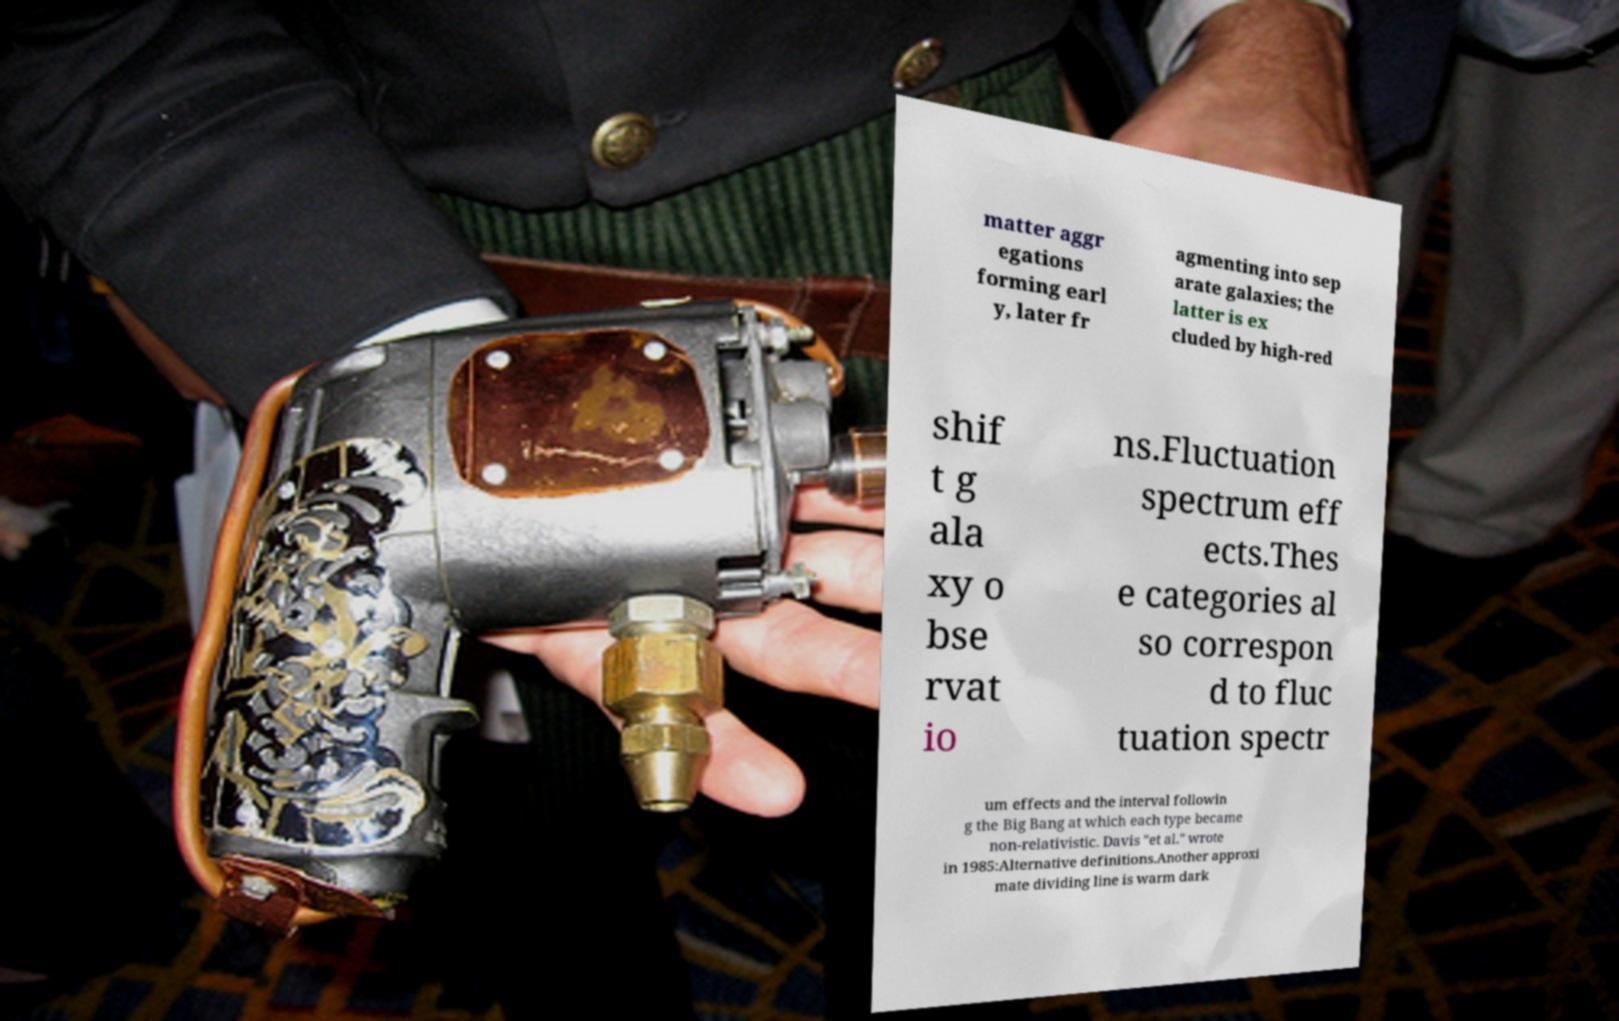Can you read and provide the text displayed in the image?This photo seems to have some interesting text. Can you extract and type it out for me? matter aggr egations forming earl y, later fr agmenting into sep arate galaxies; the latter is ex cluded by high-red shif t g ala xy o bse rvat io ns.Fluctuation spectrum eff ects.Thes e categories al so correspon d to fluc tuation spectr um effects and the interval followin g the Big Bang at which each type became non-relativistic. Davis "et al." wrote in 1985:Alternative definitions.Another approxi mate dividing line is warm dark 